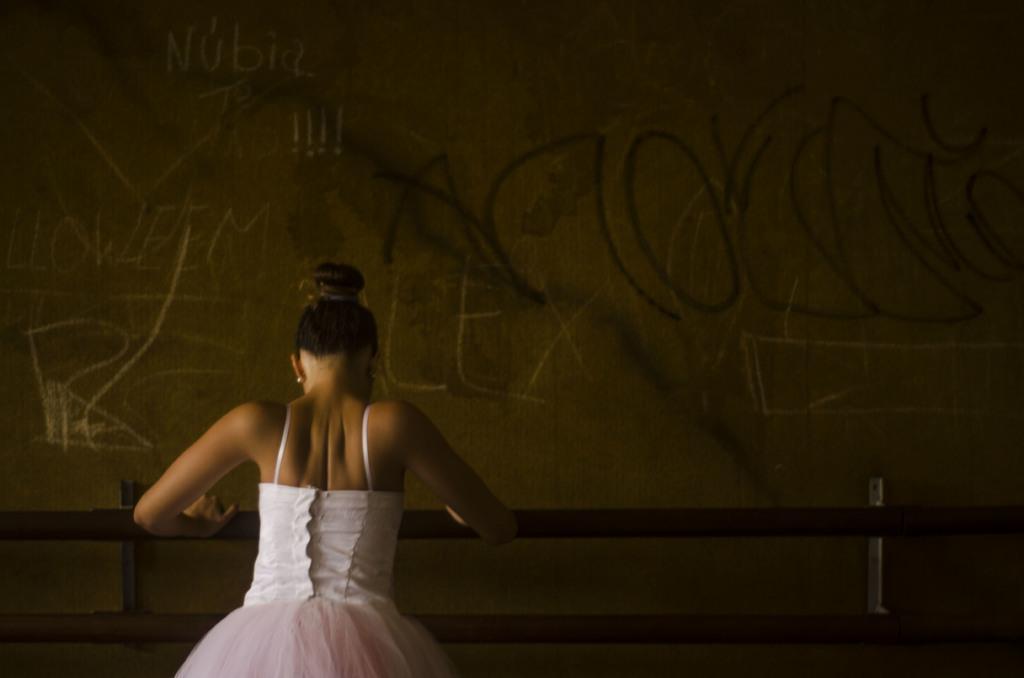How would you summarize this image in a sentence or two? In this image there is a woman standing and holding a rod , and in the background there are some scribblings on the wall. 